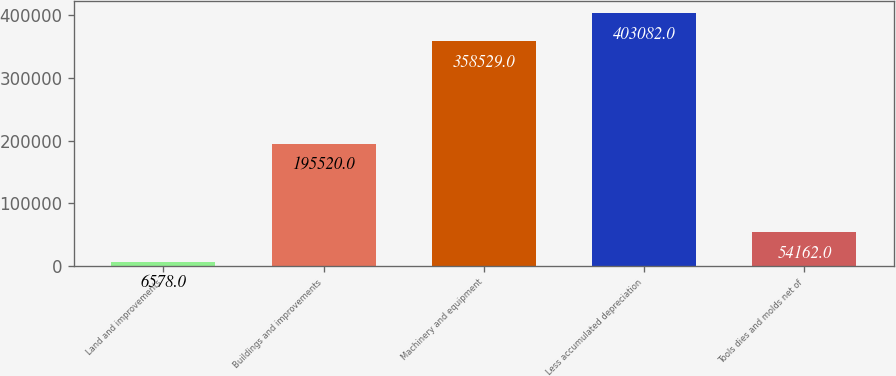Convert chart. <chart><loc_0><loc_0><loc_500><loc_500><bar_chart><fcel>Land and improvements<fcel>Buildings and improvements<fcel>Machinery and equipment<fcel>Less accumulated depreciation<fcel>Tools dies and molds net of<nl><fcel>6578<fcel>195520<fcel>358529<fcel>403082<fcel>54162<nl></chart> 